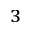Convert formula to latex. <formula><loc_0><loc_0><loc_500><loc_500>^ { 3 }</formula> 